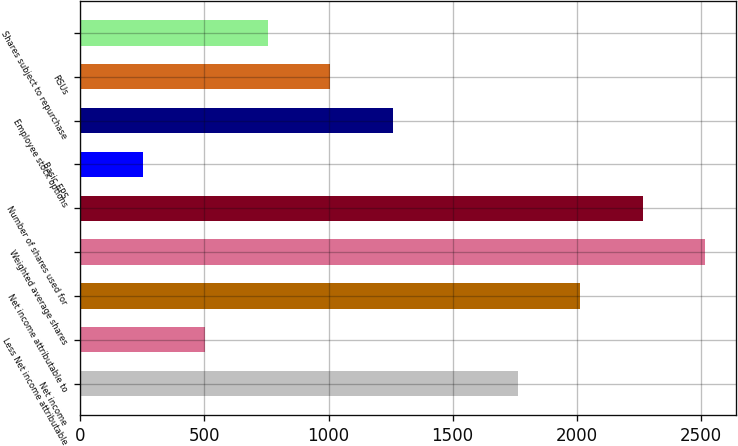Convert chart. <chart><loc_0><loc_0><loc_500><loc_500><bar_chart><fcel>Net income<fcel>Less Net income attributable<fcel>Net income attributable to<fcel>Weighted average shares<fcel>Number of shares used for<fcel>Basic EPS<fcel>Employee stock options<fcel>RSUs<fcel>Shares subject to repurchase<nl><fcel>1762.08<fcel>503.88<fcel>2013.72<fcel>2517<fcel>2265.36<fcel>252.24<fcel>1258.8<fcel>1007.16<fcel>755.52<nl></chart> 